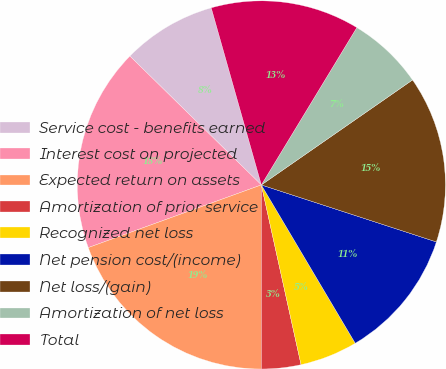Convert chart to OTSL. <chart><loc_0><loc_0><loc_500><loc_500><pie_chart><fcel>Service cost - benefits earned<fcel>Interest cost on projected<fcel>Expected return on assets<fcel>Amortization of prior service<fcel>Recognized net loss<fcel>Net pension cost/(income)<fcel>Net loss/(gain)<fcel>Amortization of net loss<fcel>Total<nl><fcel>8.27%<fcel>17.87%<fcel>19.47%<fcel>3.46%<fcel>5.06%<fcel>11.47%<fcel>14.67%<fcel>6.66%<fcel>13.07%<nl></chart> 